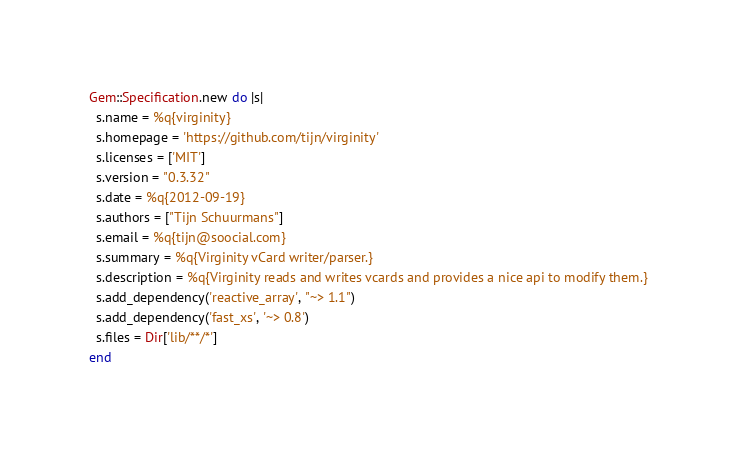Convert code to text. <code><loc_0><loc_0><loc_500><loc_500><_Ruby_>Gem::Specification.new do |s|
  s.name = %q{virginity}
  s.homepage = 'https://github.com/tijn/virginity'
  s.licenses = ['MIT']
  s.version = "0.3.32"
  s.date = %q{2012-09-19}
  s.authors = ["Tijn Schuurmans"]
  s.email = %q{tijn@soocial.com}
  s.summary = %q{Virginity vCard writer/parser.}
  s.description = %q{Virginity reads and writes vcards and provides a nice api to modify them.}
  s.add_dependency('reactive_array', "~> 1.1")
  s.add_dependency('fast_xs', '~> 0.8')
  s.files = Dir['lib/**/*']
end
</code> 